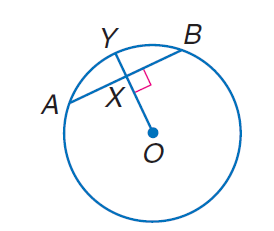Answer the mathemtical geometry problem and directly provide the correct option letter.
Question: Circle O has a radius of 10, A B = 10 and m \overrightarrow A B = 60. Find m \widehat A X.
Choices: A: 5 B: 10 C: 20 D: 30 A 